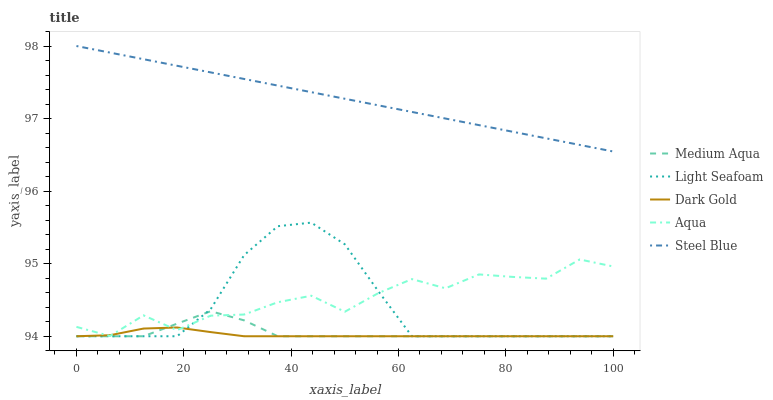Does Dark Gold have the minimum area under the curve?
Answer yes or no. Yes. Does Steel Blue have the maximum area under the curve?
Answer yes or no. Yes. Does Light Seafoam have the minimum area under the curve?
Answer yes or no. No. Does Light Seafoam have the maximum area under the curve?
Answer yes or no. No. Is Steel Blue the smoothest?
Answer yes or no. Yes. Is Aqua the roughest?
Answer yes or no. Yes. Is Light Seafoam the smoothest?
Answer yes or no. No. Is Light Seafoam the roughest?
Answer yes or no. No. Does Light Seafoam have the lowest value?
Answer yes or no. Yes. Does Steel Blue have the lowest value?
Answer yes or no. No. Does Steel Blue have the highest value?
Answer yes or no. Yes. Does Light Seafoam have the highest value?
Answer yes or no. No. Is Dark Gold less than Steel Blue?
Answer yes or no. Yes. Is Steel Blue greater than Medium Aqua?
Answer yes or no. Yes. Does Medium Aqua intersect Aqua?
Answer yes or no. Yes. Is Medium Aqua less than Aqua?
Answer yes or no. No. Is Medium Aqua greater than Aqua?
Answer yes or no. No. Does Dark Gold intersect Steel Blue?
Answer yes or no. No. 